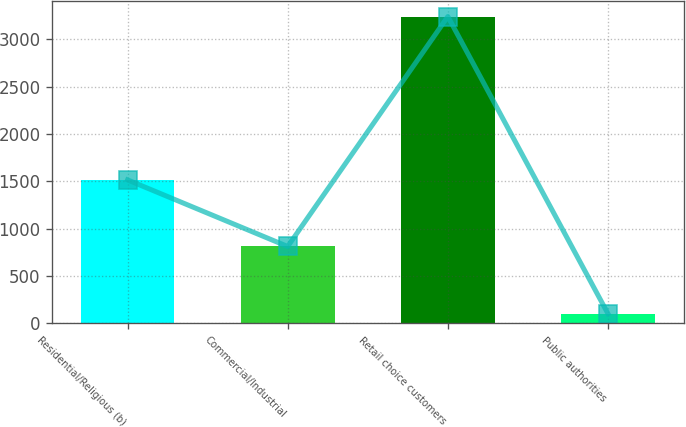<chart> <loc_0><loc_0><loc_500><loc_500><bar_chart><fcel>Residential/Religious (b)<fcel>Commercial/Industrial<fcel>Retail choice customers<fcel>Public authorities<nl><fcel>1515<fcel>812<fcel>3240<fcel>102<nl></chart> 